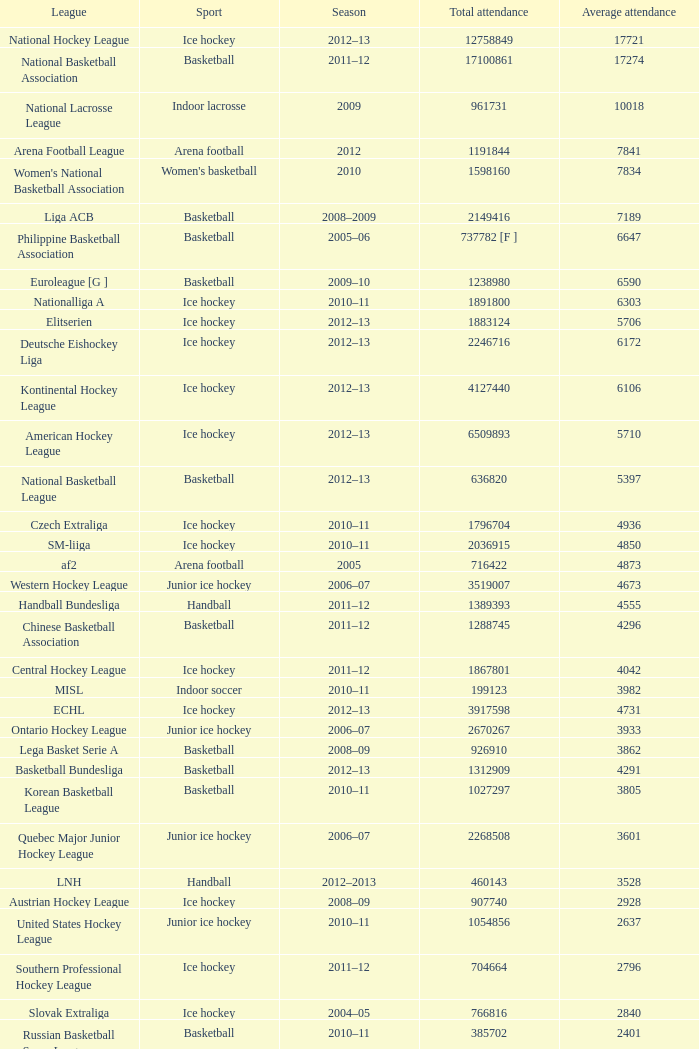What was the highest average attendance in the 2009 season? 10018.0. 